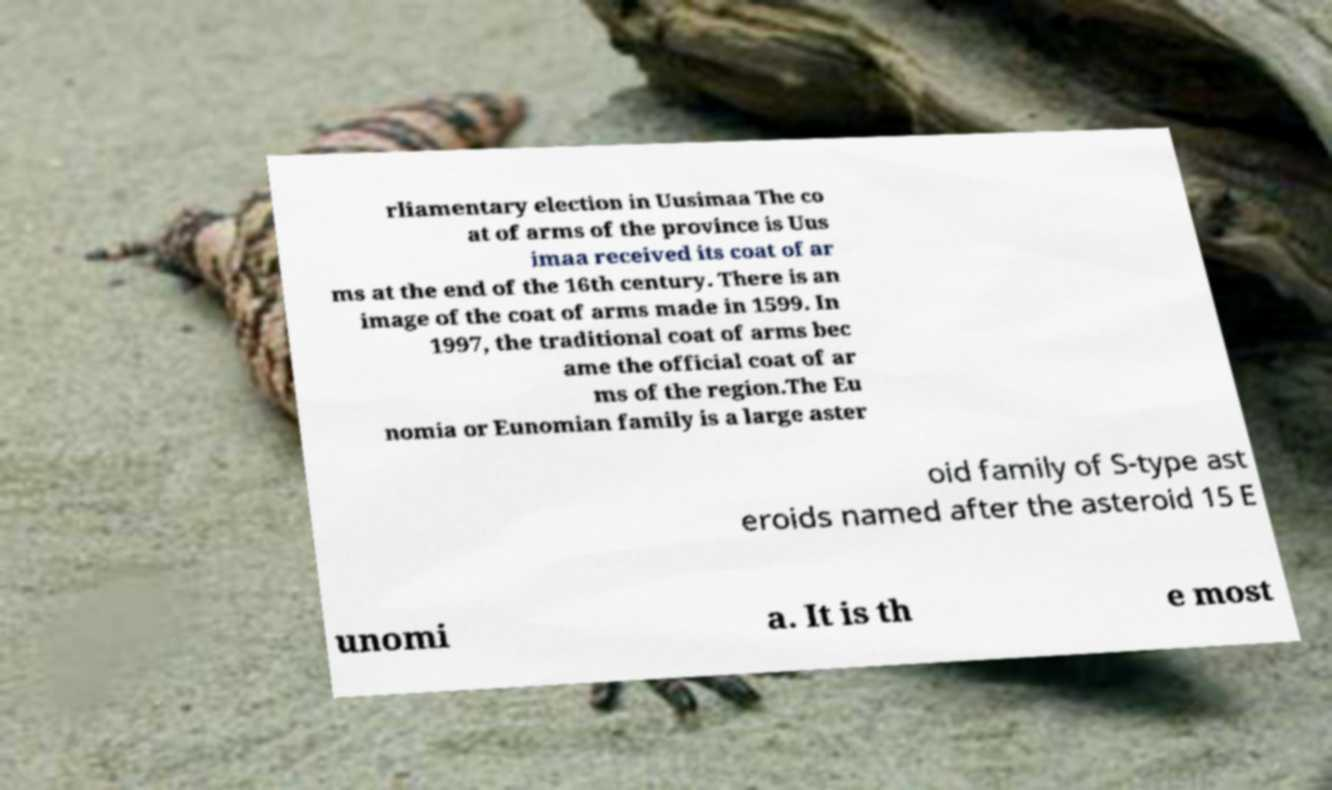I need the written content from this picture converted into text. Can you do that? rliamentary election in Uusimaa The co at of arms of the province is Uus imaa received its coat of ar ms at the end of the 16th century. There is an image of the coat of arms made in 1599. In 1997, the traditional coat of arms bec ame the official coat of ar ms of the region.The Eu nomia or Eunomian family is a large aster oid family of S-type ast eroids named after the asteroid 15 E unomi a. It is th e most 